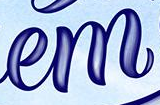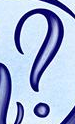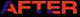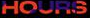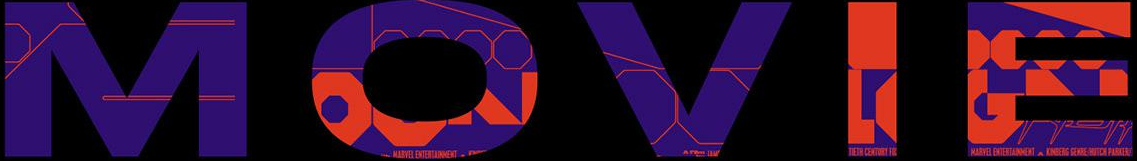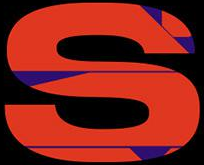Read the text from these images in sequence, separated by a semicolon. em; ?; AFTER; HOURS; MOVIE; S 